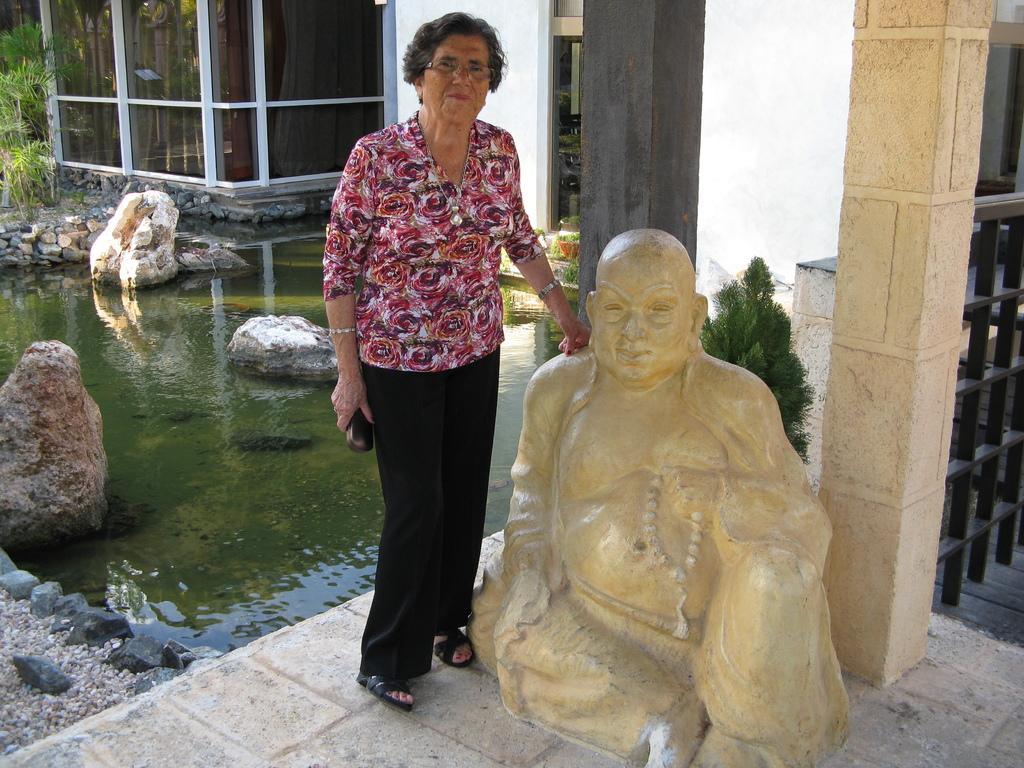Can you describe this image briefly? This is the woman standing and smiling. This looks like a small pond. These are the rocks. This is the sculpture. I can see trees. This is the pillar. Here is the glass door. 